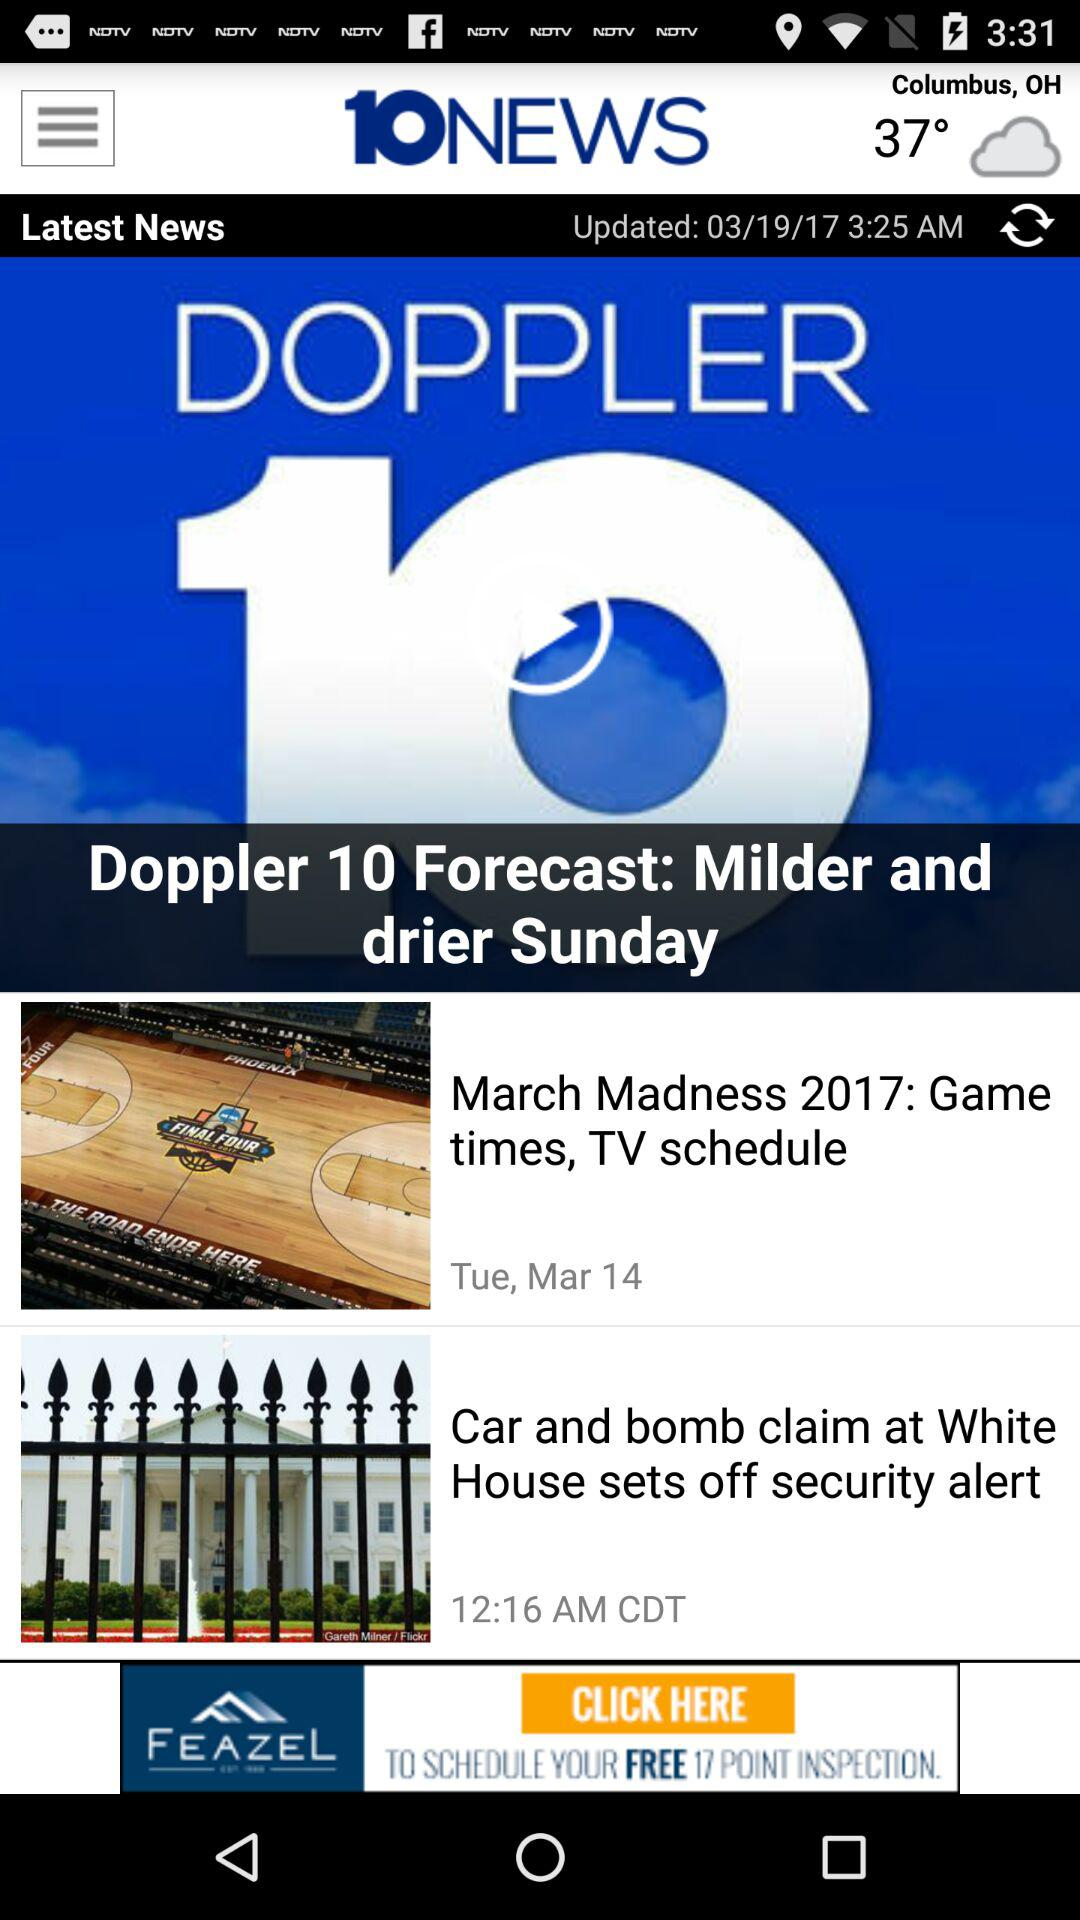What set off the security alert at the White House? The security alert at the White House was set off by a car and bomb claim. 